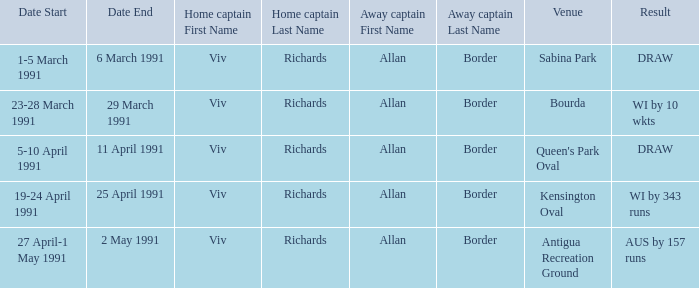What dates contained matches at the venue Bourda? 23,24,25,27,28 March 1991. Can you parse all the data within this table? {'header': ['Date Start', 'Date End', 'Home captain First Name', 'Home captain Last Name', 'Away captain First Name', 'Away captain Last Name', 'Venue', 'Result'], 'rows': [['1-5 March 1991', '6 March 1991', 'Viv', 'Richards', 'Allan', 'Border', 'Sabina Park', 'DRAW'], ['23-28 March 1991', '29 March 1991', 'Viv', 'Richards', 'Allan', 'Border', 'Bourda', 'WI by 10 wkts'], ['5-10 April 1991', '11 April 1991', 'Viv', 'Richards', 'Allan', 'Border', "Queen's Park Oval", 'DRAW'], ['19-24 April 1991', '25 April 1991', 'Viv', 'Richards', 'Allan', 'Border', 'Kensington Oval', 'WI by 343 runs'], ['27 April-1 May 1991', '2 May 1991', 'Viv', 'Richards', 'Allan', 'Border', 'Antigua Recreation Ground', 'AUS by 157 runs']]} 